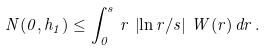<formula> <loc_0><loc_0><loc_500><loc_500>N ( 0 , h _ { 1 } ) \leq \int _ { 0 } ^ { s } \, r \, \left | \ln r / s \right | \, W ( r ) \, d r \, .</formula> 